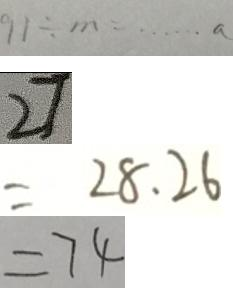Convert formula to latex. <formula><loc_0><loc_0><loc_500><loc_500>9 1 \div m = \cdots a 
 2 7 
 = 2 8 . 2 6 
 = 7 4</formula> 